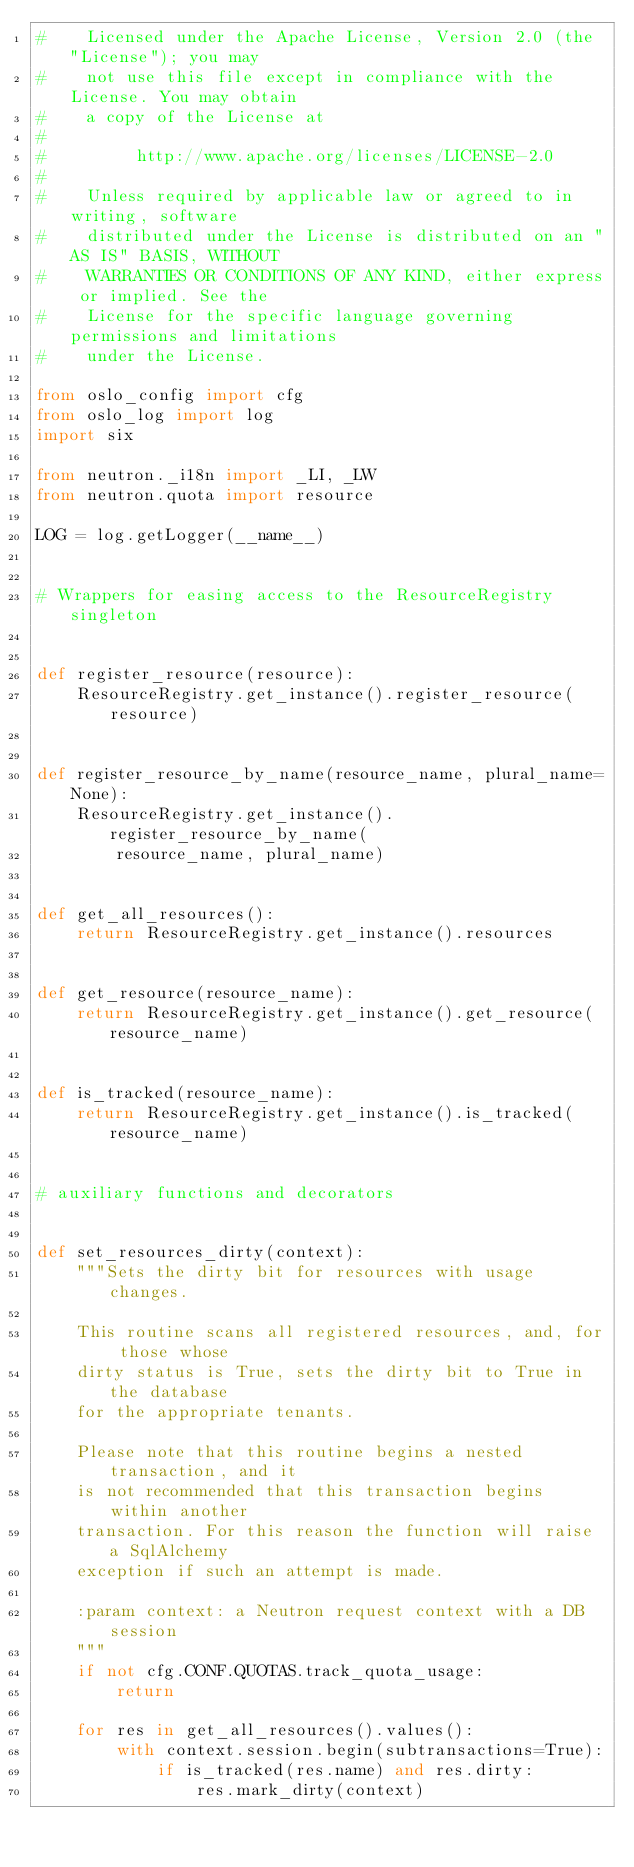<code> <loc_0><loc_0><loc_500><loc_500><_Python_>#    Licensed under the Apache License, Version 2.0 (the "License"); you may
#    not use this file except in compliance with the License. You may obtain
#    a copy of the License at
#
#         http://www.apache.org/licenses/LICENSE-2.0
#
#    Unless required by applicable law or agreed to in writing, software
#    distributed under the License is distributed on an "AS IS" BASIS, WITHOUT
#    WARRANTIES OR CONDITIONS OF ANY KIND, either express or implied. See the
#    License for the specific language governing permissions and limitations
#    under the License.

from oslo_config import cfg
from oslo_log import log
import six

from neutron._i18n import _LI, _LW
from neutron.quota import resource

LOG = log.getLogger(__name__)


# Wrappers for easing access to the ResourceRegistry singleton


def register_resource(resource):
    ResourceRegistry.get_instance().register_resource(resource)


def register_resource_by_name(resource_name, plural_name=None):
    ResourceRegistry.get_instance().register_resource_by_name(
        resource_name, plural_name)


def get_all_resources():
    return ResourceRegistry.get_instance().resources


def get_resource(resource_name):
    return ResourceRegistry.get_instance().get_resource(resource_name)


def is_tracked(resource_name):
    return ResourceRegistry.get_instance().is_tracked(resource_name)


# auxiliary functions and decorators


def set_resources_dirty(context):
    """Sets the dirty bit for resources with usage changes.

    This routine scans all registered resources, and, for those whose
    dirty status is True, sets the dirty bit to True in the database
    for the appropriate tenants.

    Please note that this routine begins a nested transaction, and it
    is not recommended that this transaction begins within another
    transaction. For this reason the function will raise a SqlAlchemy
    exception if such an attempt is made.

    :param context: a Neutron request context with a DB session
    """
    if not cfg.CONF.QUOTAS.track_quota_usage:
        return

    for res in get_all_resources().values():
        with context.session.begin(subtransactions=True):
            if is_tracked(res.name) and res.dirty:
                res.mark_dirty(context)

</code> 